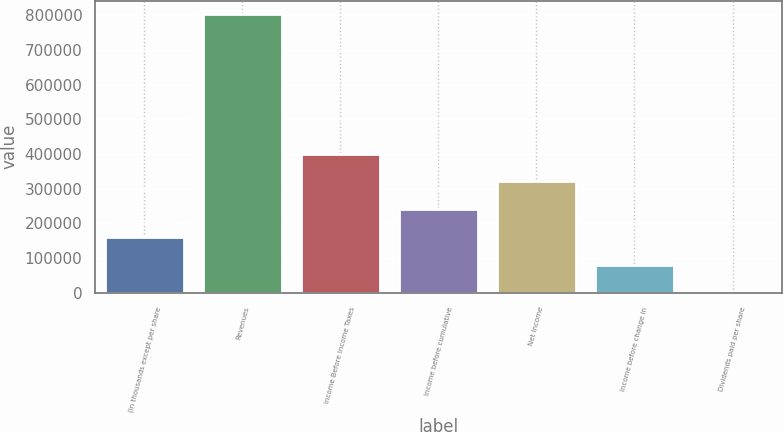Convert chart. <chart><loc_0><loc_0><loc_500><loc_500><bar_chart><fcel>(in thousands except per share<fcel>Revenues<fcel>Income Before Income Taxes<fcel>Income before cumulative<fcel>Net Income<fcel>Income before change in<fcel>Dividends paid per share<nl><fcel>160484<fcel>802417<fcel>401209<fcel>240725<fcel>320967<fcel>80241.9<fcel>0.2<nl></chart> 